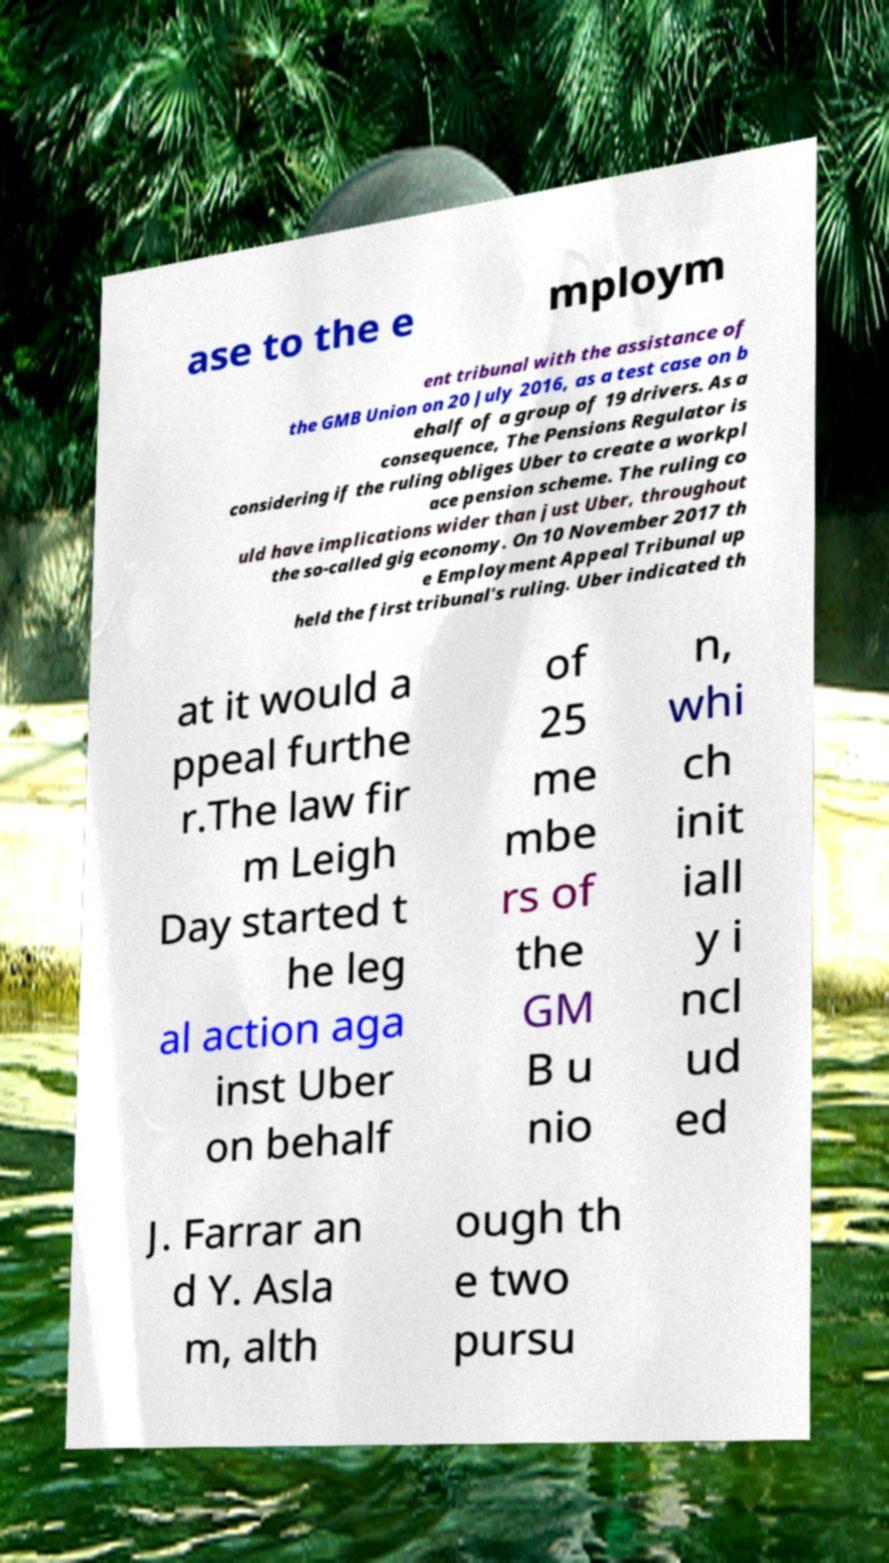For documentation purposes, I need the text within this image transcribed. Could you provide that? ase to the e mploym ent tribunal with the assistance of the GMB Union on 20 July 2016, as a test case on b ehalf of a group of 19 drivers. As a consequence, The Pensions Regulator is considering if the ruling obliges Uber to create a workpl ace pension scheme. The ruling co uld have implications wider than just Uber, throughout the so-called gig economy. On 10 November 2017 th e Employment Appeal Tribunal up held the first tribunal's ruling. Uber indicated th at it would a ppeal furthe r.The law fir m Leigh Day started t he leg al action aga inst Uber on behalf of 25 me mbe rs of the GM B u nio n, whi ch init iall y i ncl ud ed J. Farrar an d Y. Asla m, alth ough th e two pursu 